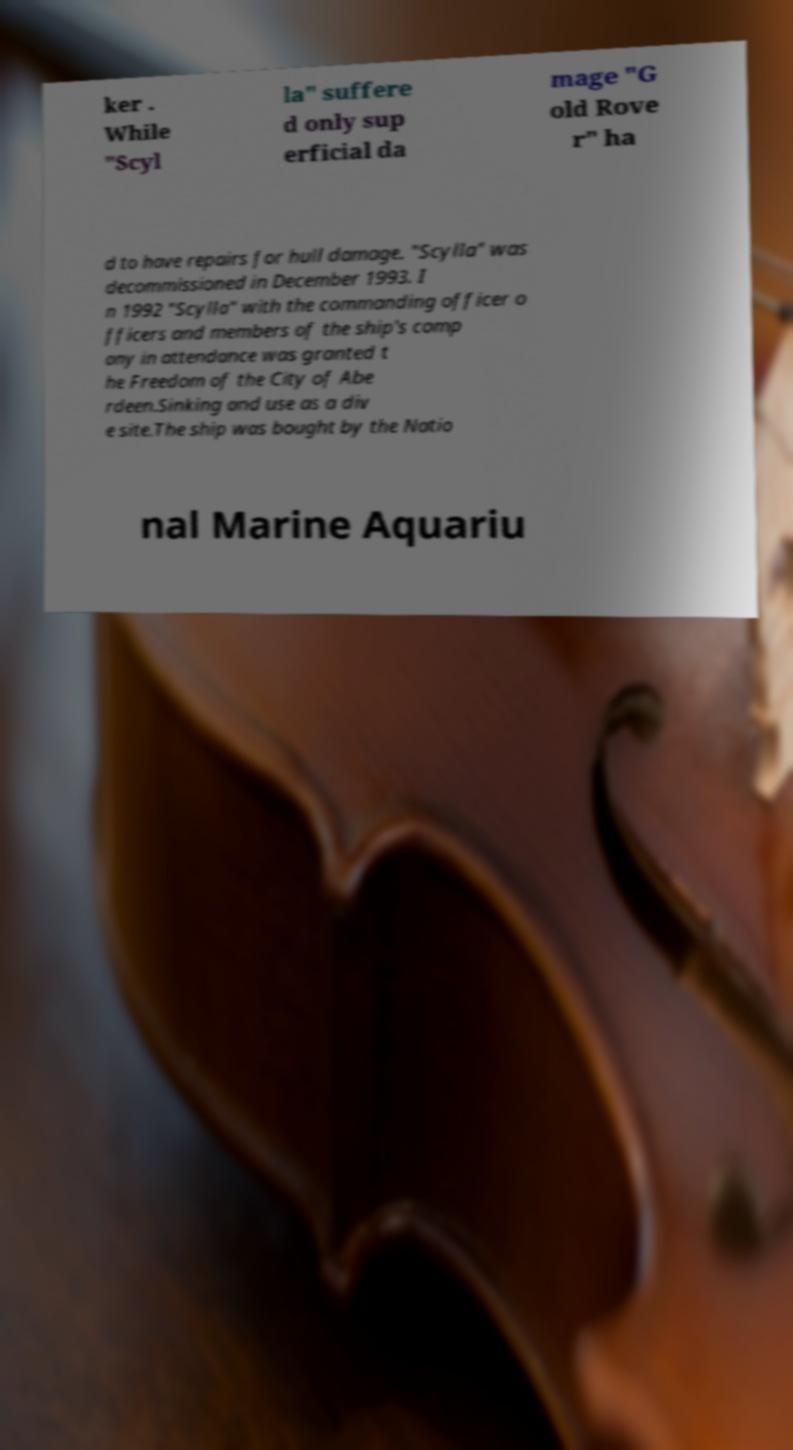Please identify and transcribe the text found in this image. ker . While "Scyl la" suffere d only sup erficial da mage "G old Rove r" ha d to have repairs for hull damage. "Scylla" was decommissioned in December 1993. I n 1992 "Scylla" with the commanding officer o fficers and members of the ship's comp any in attendance was granted t he Freedom of the City of Abe rdeen.Sinking and use as a div e site.The ship was bought by the Natio nal Marine Aquariu 